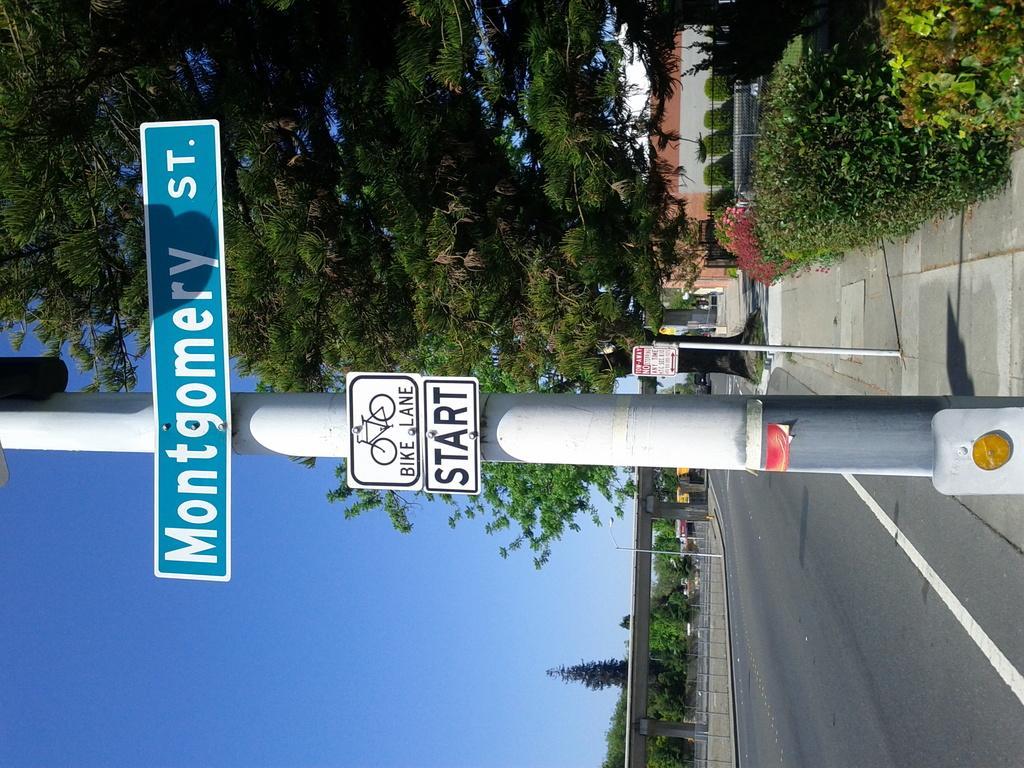Can you describe this image briefly? In this image, these are the boards, which are attached to a pole. This is a road. I can see the trees with branches and leaves. These are the bushes. At the bottom of the image, that looks like a flyover with the pillars. This is the sky. I think this is the pathway. 